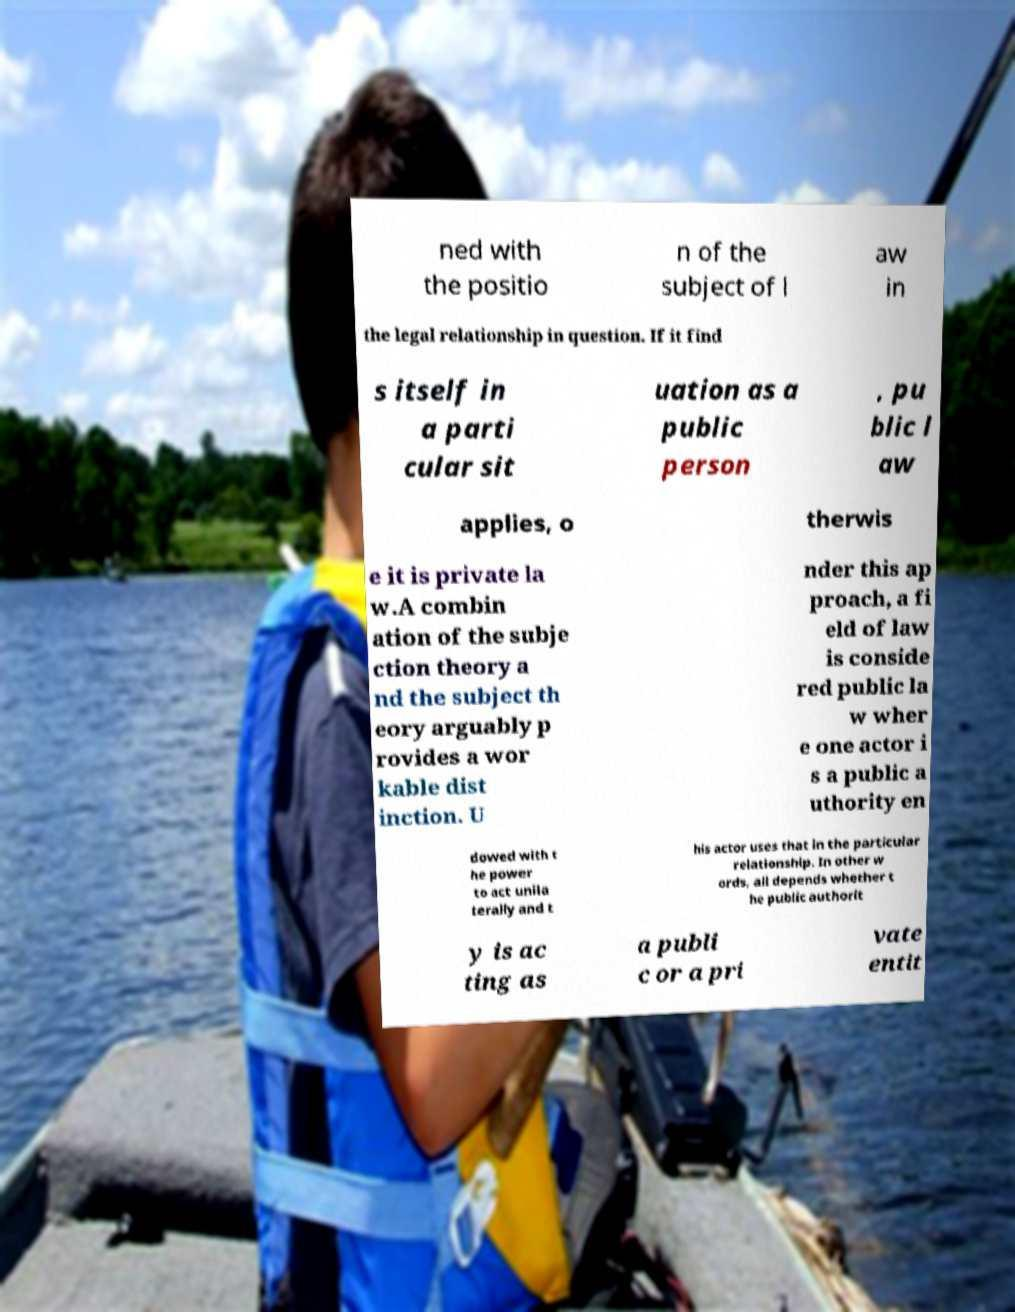Please read and relay the text visible in this image. What does it say? ned with the positio n of the subject of l aw in the legal relationship in question. If it find s itself in a parti cular sit uation as a public person , pu blic l aw applies, o therwis e it is private la w.A combin ation of the subje ction theory a nd the subject th eory arguably p rovides a wor kable dist inction. U nder this ap proach, a fi eld of law is conside red public la w wher e one actor i s a public a uthority en dowed with t he power to act unila terally and t his actor uses that in the particular relationship. In other w ords, all depends whether t he public authorit y is ac ting as a publi c or a pri vate entit 